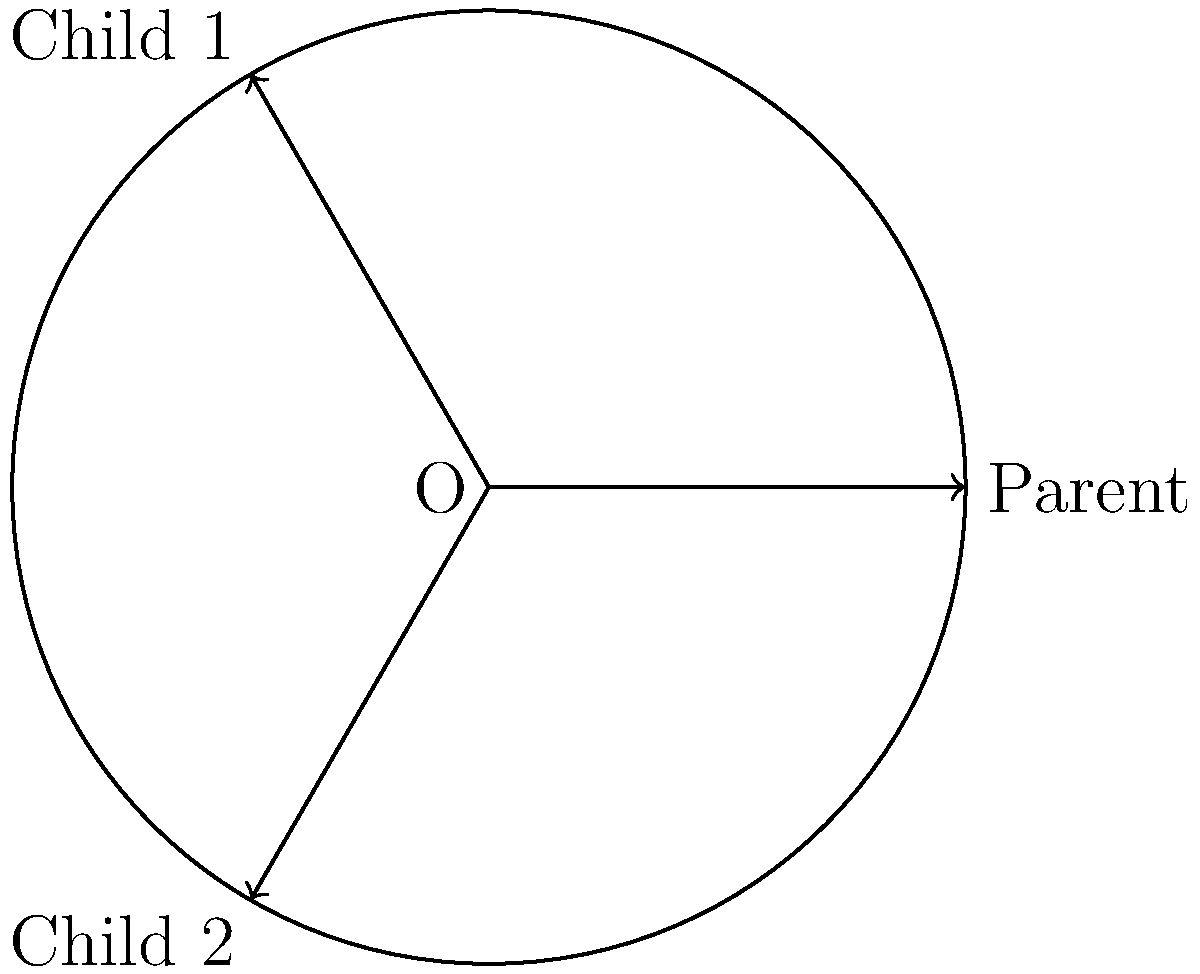In a family structure diagram, a single parent and two children are represented by a circle with three equally spaced radii. If the circle has a radius of 5 units, what is the distance between the endpoints of any two adjacent radii? To solve this problem, we'll follow these steps:

1. Recognize that the three radii form an equilateral triangle inscribed in the circle.
2. The side length of this equilateral triangle is what we need to calculate.
3. In an equilateral triangle inscribed in a circle, the side length (s) is related to the radius (r) by the formula: $s = r\sqrt{3}$

Let's calculate:

4. Given: radius $r = 5$ units
5. Apply the formula: $s = 5\sqrt{3}$ units

Therefore, the distance between the endpoints of any two adjacent radii is $5\sqrt{3}$ units.
Answer: $5\sqrt{3}$ units 